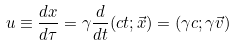Convert formula to latex. <formula><loc_0><loc_0><loc_500><loc_500>u \equiv \frac { d x } { d \tau } = \gamma \frac { d } { d t } ( c t ; \vec { x } ) = ( \gamma c ; \gamma \vec { v } )</formula> 